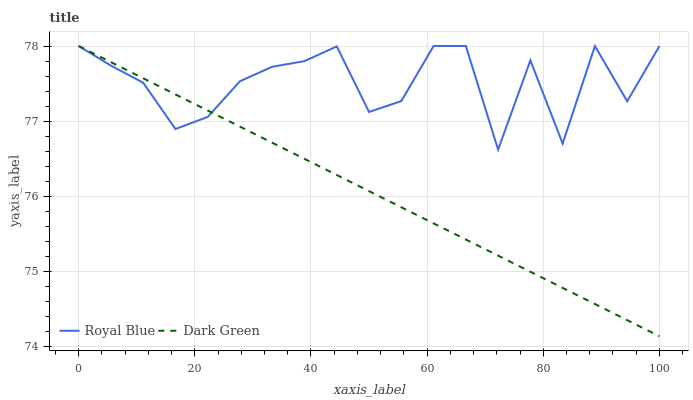Does Dark Green have the minimum area under the curve?
Answer yes or no. Yes. Does Royal Blue have the maximum area under the curve?
Answer yes or no. Yes. Does Dark Green have the maximum area under the curve?
Answer yes or no. No. Is Dark Green the smoothest?
Answer yes or no. Yes. Is Royal Blue the roughest?
Answer yes or no. Yes. Is Dark Green the roughest?
Answer yes or no. No. Does Dark Green have the lowest value?
Answer yes or no. Yes. Does Dark Green have the highest value?
Answer yes or no. Yes. Does Royal Blue intersect Dark Green?
Answer yes or no. Yes. Is Royal Blue less than Dark Green?
Answer yes or no. No. Is Royal Blue greater than Dark Green?
Answer yes or no. No. 